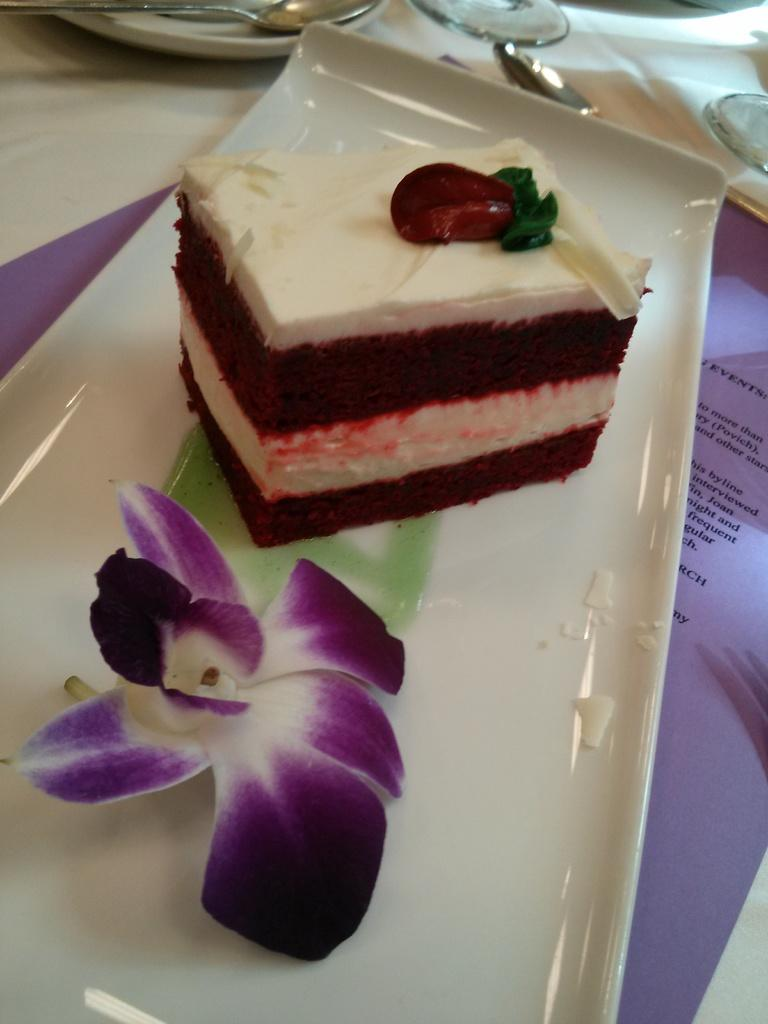What is the main food item visible on a plate in the image? There is a food item on a plate in the image, but the specific type of food cannot be determined from the provided facts. How many plates are visible in the image? There are plates in the image, but the exact number cannot be determined from the provided facts. What utensils are present in the image? There are spoons in the image. Where are the plates and spoons located? The plates and spoons are on a table. What type of lock is used to secure the food in the image? There is no lock present in the image, as it features plates, spoons, and a food item on a plate. 